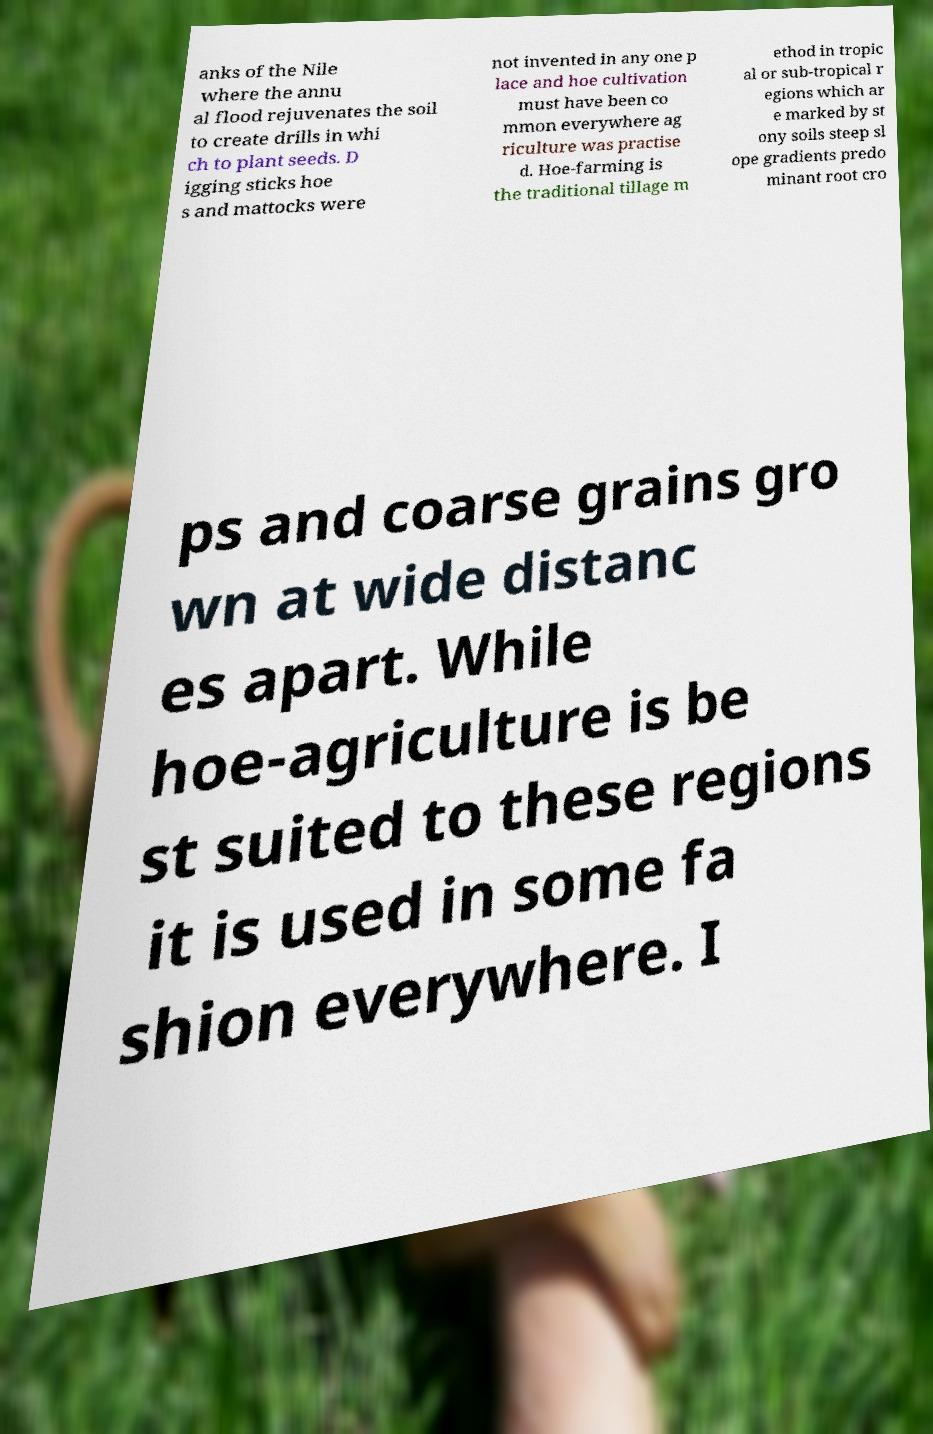Please identify and transcribe the text found in this image. anks of the Nile where the annu al flood rejuvenates the soil to create drills in whi ch to plant seeds. D igging sticks hoe s and mattocks were not invented in any one p lace and hoe cultivation must have been co mmon everywhere ag riculture was practise d. Hoe-farming is the traditional tillage m ethod in tropic al or sub-tropical r egions which ar e marked by st ony soils steep sl ope gradients predo minant root cro ps and coarse grains gro wn at wide distanc es apart. While hoe-agriculture is be st suited to these regions it is used in some fa shion everywhere. I 